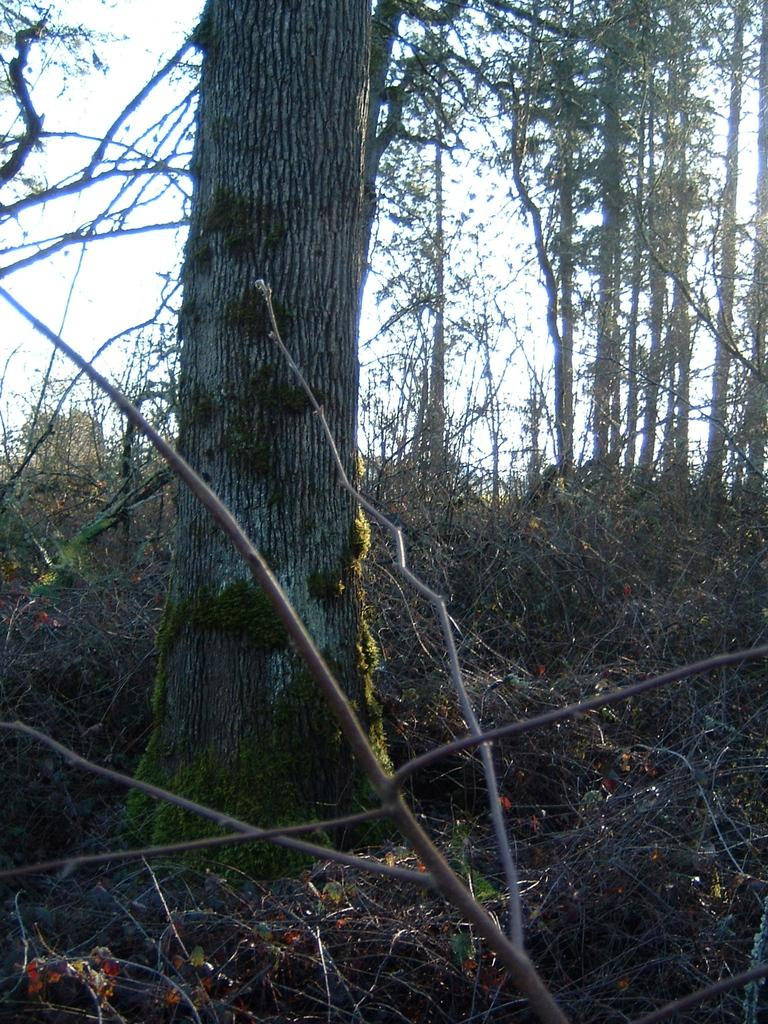What is the main subject of the image? The main subject of the image is a tree trunk. What can be seen around the tree trunk? There are many dry plants around the tree trunk. What other features are present in the image? There are tall trees in the image. What type of dinosaurs can be seen roaming around the tree trunk in the image? There are no dinosaurs present in the image; it features a tree trunk and dry plants. What nation is depicted in the image? The image does not depict any nation; it focuses on a tree trunk and its surroundings. 